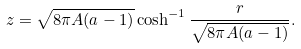<formula> <loc_0><loc_0><loc_500><loc_500>z = \sqrt { 8 \pi A ( a - 1 ) } \cosh ^ { - 1 } \frac { r } { \sqrt { 8 \pi A ( a - 1 ) } } .</formula> 